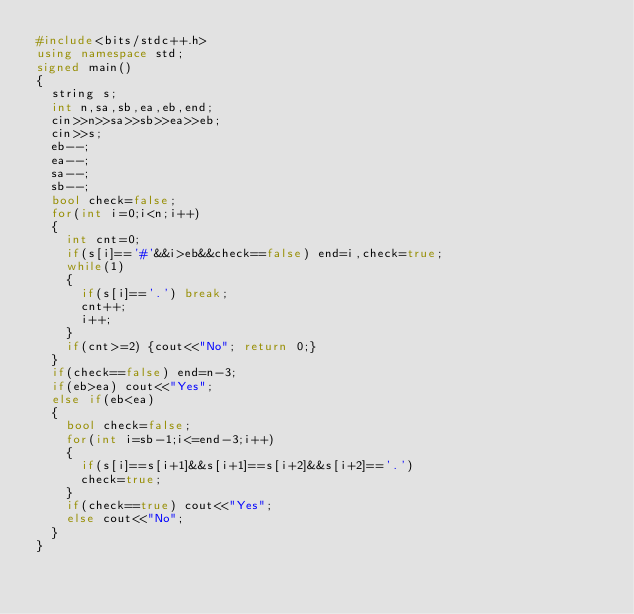<code> <loc_0><loc_0><loc_500><loc_500><_C++_>#include<bits/stdc++.h>
using namespace std;
signed main()
{
	string s;
	int n,sa,sb,ea,eb,end;
	cin>>n>>sa>>sb>>ea>>eb;
	cin>>s;
	eb--;
	ea--;
	sa--;
	sb--;
	bool check=false;
	for(int i=0;i<n;i++)
	{
		int cnt=0;
		if(s[i]=='#'&&i>eb&&check==false) end=i,check=true;
		while(1)
		{
			if(s[i]=='.') break;
			cnt++;
			i++;
		}
		if(cnt>=2) {cout<<"No"; return 0;}
	}
	if(check==false) end=n-3;
	if(eb>ea) cout<<"Yes";
	else if(eb<ea)
	{
		bool check=false;
		for(int i=sb-1;i<=end-3;i++)
		{
			if(s[i]==s[i+1]&&s[i+1]==s[i+2]&&s[i+2]=='.')
			check=true;
		}	
		if(check==true) cout<<"Yes";
		else cout<<"No";
	}
}</code> 